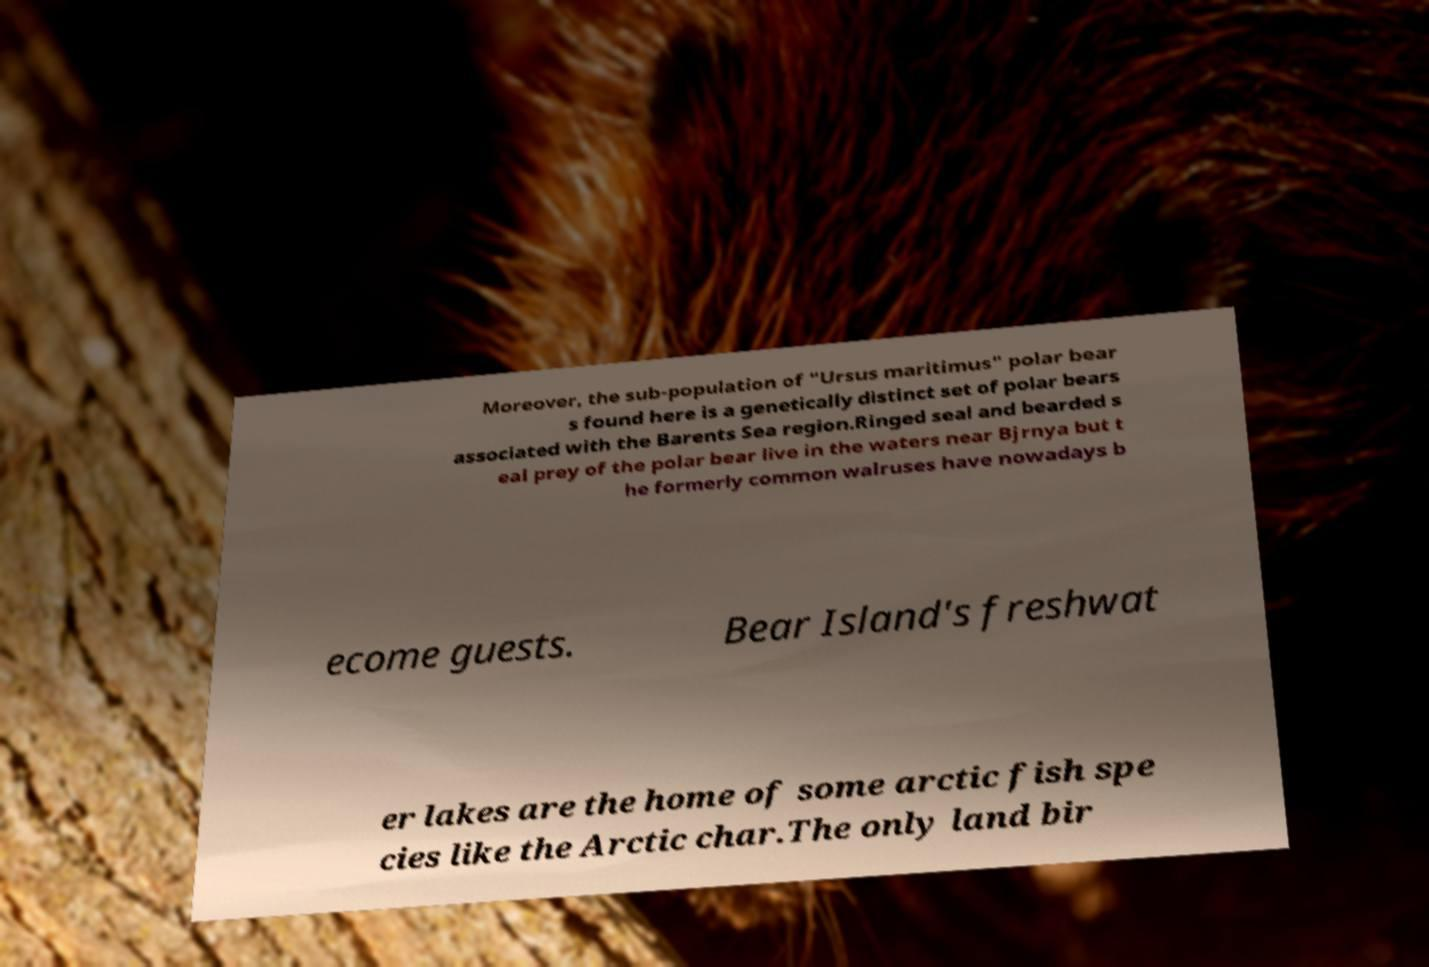Please read and relay the text visible in this image. What does it say? Moreover, the sub-population of "Ursus maritimus" polar bear s found here is a genetically distinct set of polar bears associated with the Barents Sea region.Ringed seal and bearded s eal prey of the polar bear live in the waters near Bjrnya but t he formerly common walruses have nowadays b ecome guests. Bear Island's freshwat er lakes are the home of some arctic fish spe cies like the Arctic char.The only land bir 